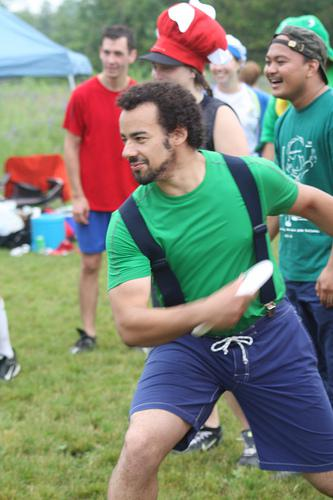Question: when is this taking place?
Choices:
A. Nighttime.
B. Afternoon.
C. Morning.
D. Daytime.
Answer with the letter. Answer: D Question: what color is the frisbee?
Choices:
A. Green.
B. Blue.
C. White.
D. Orange.
Answer with the letter. Answer: C Question: where are these people standing?
Choices:
A. Mud.
B. Dirt.
C. Sand.
D. Grass.
Answer with the letter. Answer: D Question: where is this taking place?
Choices:
A. In the ZOO.
B. In Six Flags Over Texas.
C. In a park.
D. On a street.
Answer with the letter. Answer: C 